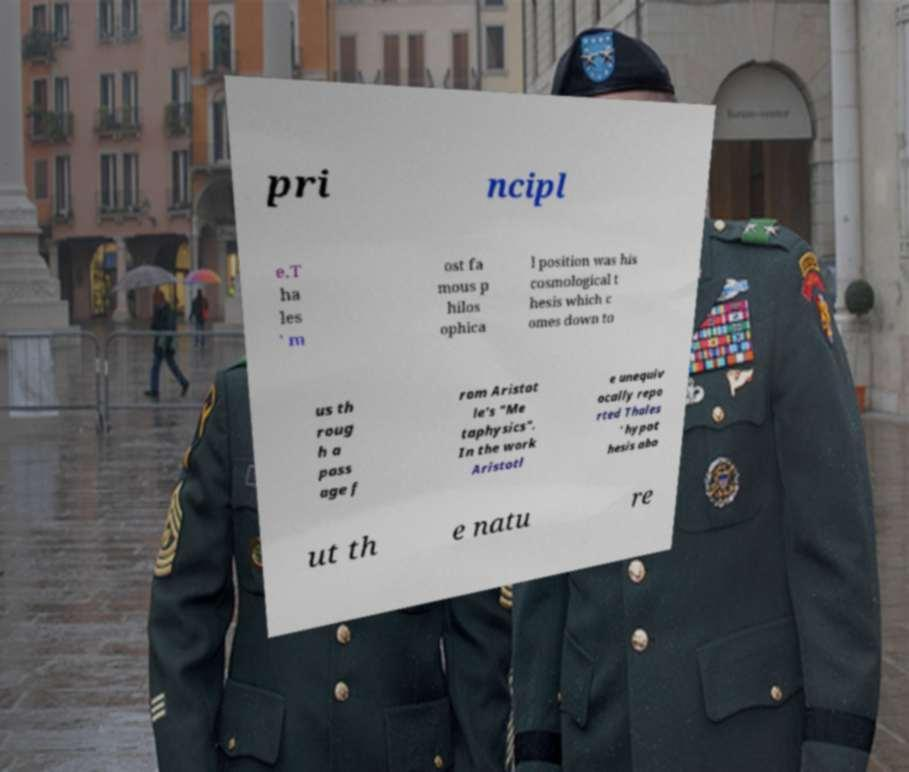There's text embedded in this image that I need extracted. Can you transcribe it verbatim? pri ncipl e.T ha les ' m ost fa mous p hilos ophica l position was his cosmological t hesis which c omes down to us th roug h a pass age f rom Aristot le's "Me taphysics". In the work Aristotl e unequiv ocally repo rted Thales ' hypot hesis abo ut th e natu re 